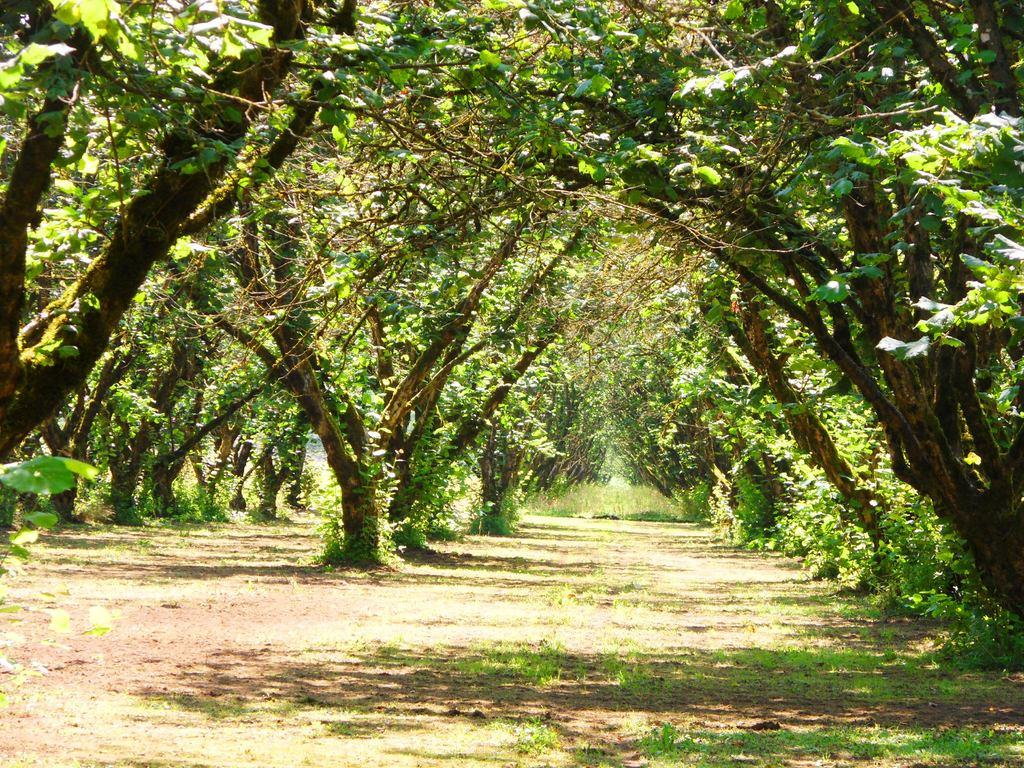What type of vegetation can be seen in the image? There are trees and plants in the image. What is visible beneath the trees and plants? The ground is visible in the image. Where is the market located in the image? There is no market present in the image. What type of carriage can be seen in the image? There is no carriage present in the image. 